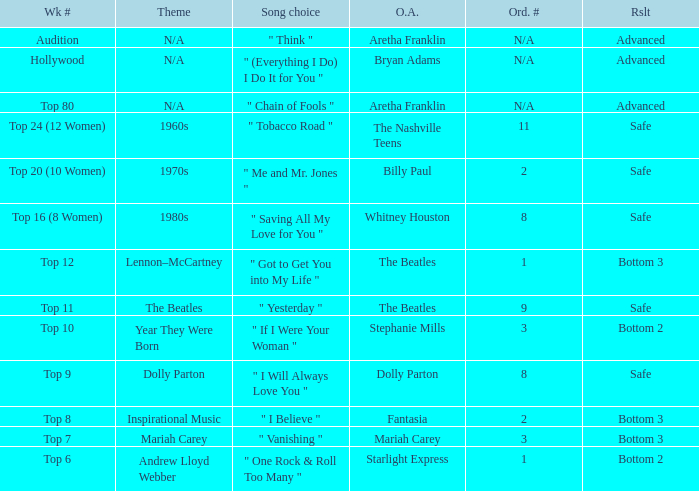Name the order number for the beatles and result is safe 9.0. 